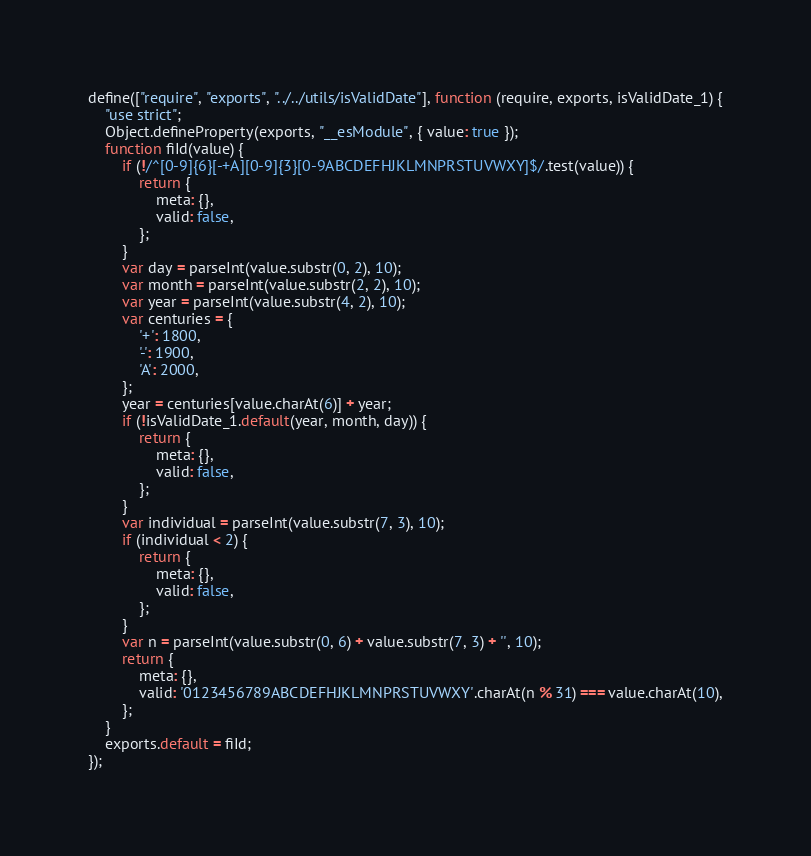<code> <loc_0><loc_0><loc_500><loc_500><_JavaScript_>define(["require", "exports", "../../utils/isValidDate"], function (require, exports, isValidDate_1) {
    "use strict";
    Object.defineProperty(exports, "__esModule", { value: true });
    function fiId(value) {
        if (!/^[0-9]{6}[-+A][0-9]{3}[0-9ABCDEFHJKLMNPRSTUVWXY]$/.test(value)) {
            return {
                meta: {},
                valid: false,
            };
        }
        var day = parseInt(value.substr(0, 2), 10);
        var month = parseInt(value.substr(2, 2), 10);
        var year = parseInt(value.substr(4, 2), 10);
        var centuries = {
            '+': 1800,
            '-': 1900,
            'A': 2000,
        };
        year = centuries[value.charAt(6)] + year;
        if (!isValidDate_1.default(year, month, day)) {
            return {
                meta: {},
                valid: false,
            };
        }
        var individual = parseInt(value.substr(7, 3), 10);
        if (individual < 2) {
            return {
                meta: {},
                valid: false,
            };
        }
        var n = parseInt(value.substr(0, 6) + value.substr(7, 3) + '', 10);
        return {
            meta: {},
            valid: '0123456789ABCDEFHJKLMNPRSTUVWXY'.charAt(n % 31) === value.charAt(10),
        };
    }
    exports.default = fiId;
});
</code> 